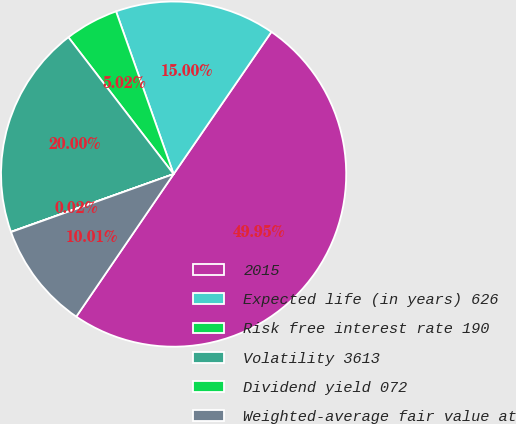Convert chart to OTSL. <chart><loc_0><loc_0><loc_500><loc_500><pie_chart><fcel>2015<fcel>Expected life (in years) 626<fcel>Risk free interest rate 190<fcel>Volatility 3613<fcel>Dividend yield 072<fcel>Weighted-average fair value at<nl><fcel>49.95%<fcel>15.0%<fcel>5.02%<fcel>20.0%<fcel>0.02%<fcel>10.01%<nl></chart> 